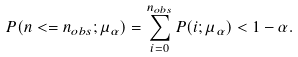<formula> <loc_0><loc_0><loc_500><loc_500>P ( n < = n _ { o b s } ; \mu _ { \alpha } ) = \sum _ { i = 0 } ^ { n _ { o b s } } P ( i ; \mu _ { \alpha } ) < 1 - \alpha .</formula> 